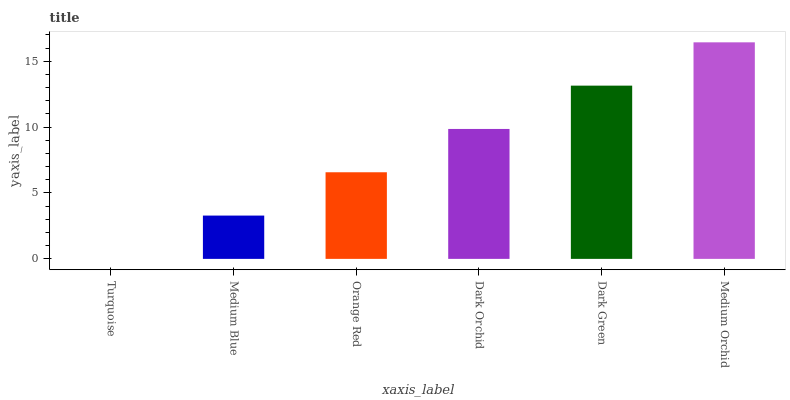Is Turquoise the minimum?
Answer yes or no. Yes. Is Medium Orchid the maximum?
Answer yes or no. Yes. Is Medium Blue the minimum?
Answer yes or no. No. Is Medium Blue the maximum?
Answer yes or no. No. Is Medium Blue greater than Turquoise?
Answer yes or no. Yes. Is Turquoise less than Medium Blue?
Answer yes or no. Yes. Is Turquoise greater than Medium Blue?
Answer yes or no. No. Is Medium Blue less than Turquoise?
Answer yes or no. No. Is Dark Orchid the high median?
Answer yes or no. Yes. Is Orange Red the low median?
Answer yes or no. Yes. Is Dark Green the high median?
Answer yes or no. No. Is Turquoise the low median?
Answer yes or no. No. 